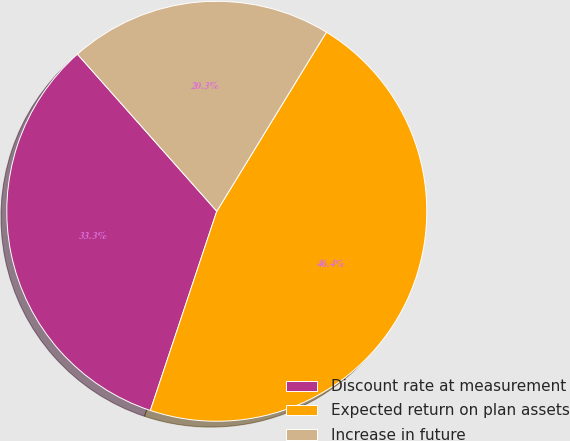Convert chart. <chart><loc_0><loc_0><loc_500><loc_500><pie_chart><fcel>Discount rate at measurement<fcel>Expected return on plan assets<fcel>Increase in future<nl><fcel>33.33%<fcel>46.38%<fcel>20.29%<nl></chart> 